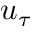<formula> <loc_0><loc_0><loc_500><loc_500>u _ { \tau }</formula> 